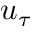<formula> <loc_0><loc_0><loc_500><loc_500>u _ { \tau }</formula> 